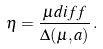Convert formula to latex. <formula><loc_0><loc_0><loc_500><loc_500>\eta = \frac { \mu d i f f } { \Delta ( \mu , a ) } \, .</formula> 